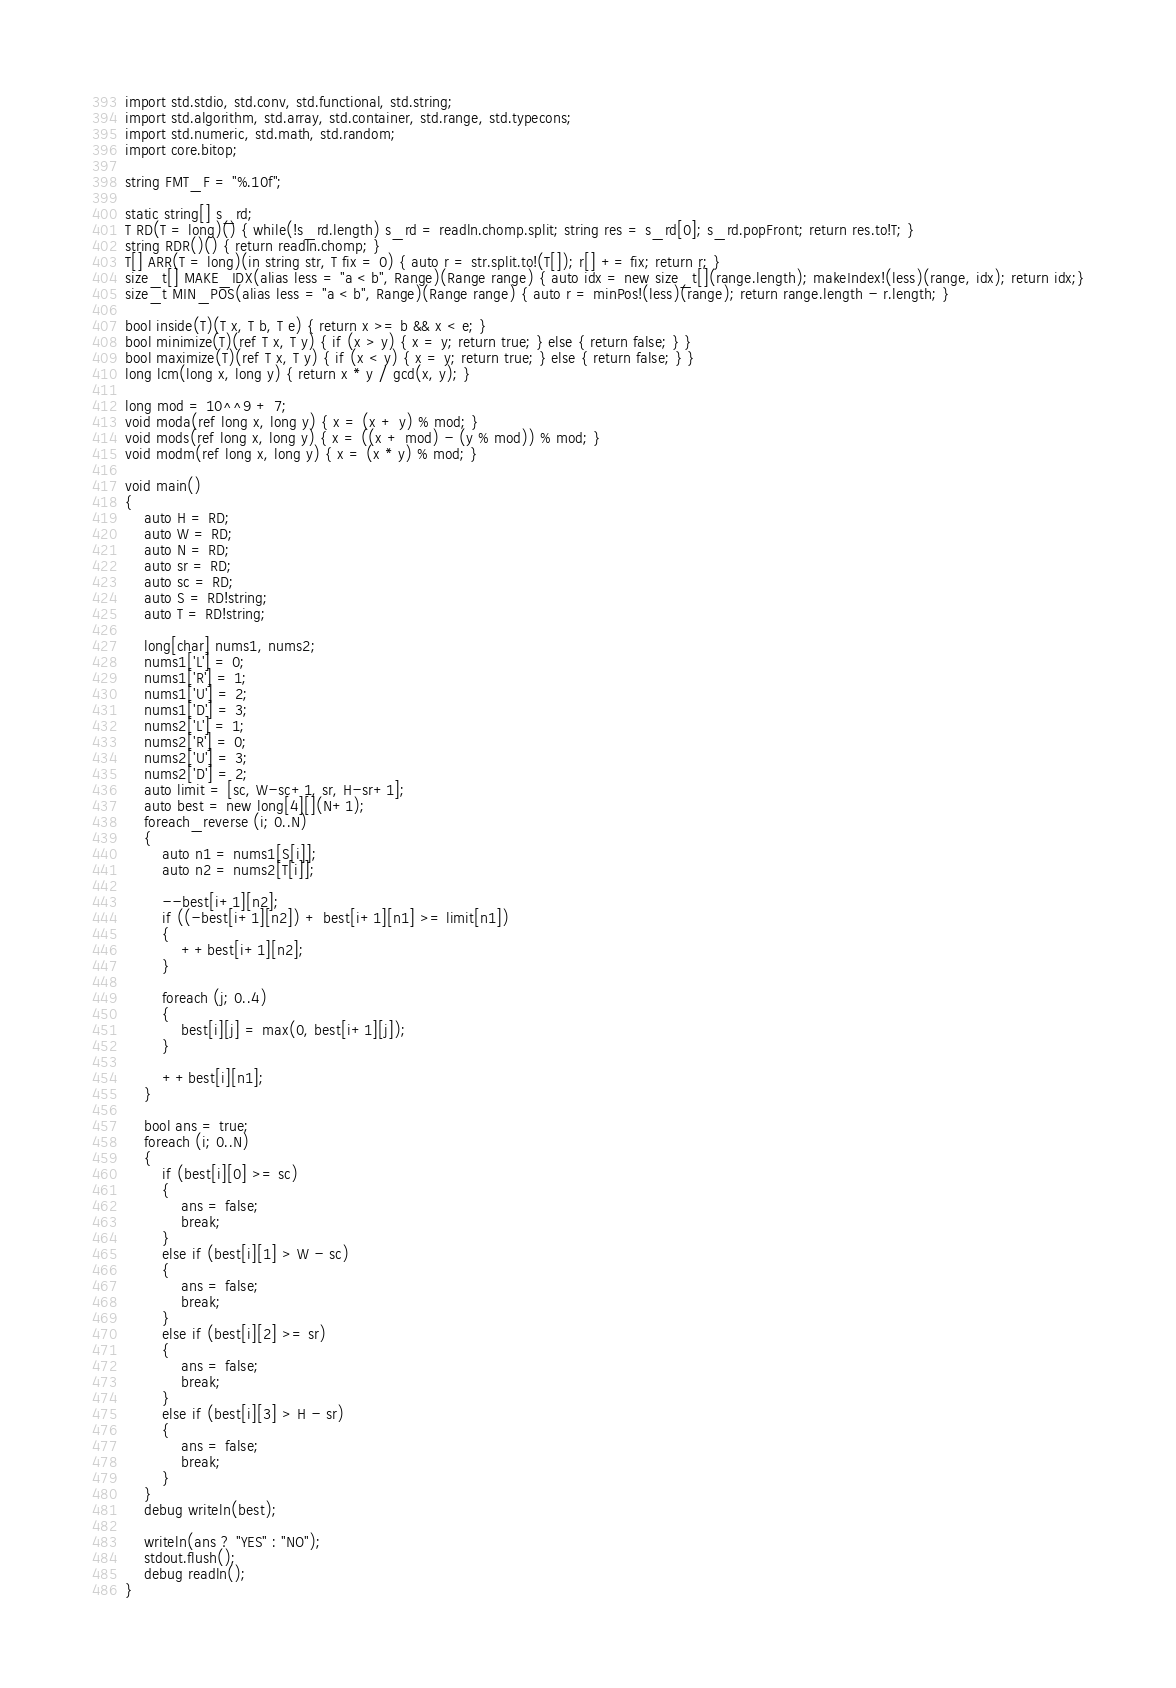<code> <loc_0><loc_0><loc_500><loc_500><_D_>import std.stdio, std.conv, std.functional, std.string;
import std.algorithm, std.array, std.container, std.range, std.typecons;
import std.numeric, std.math, std.random;
import core.bitop;

string FMT_F = "%.10f";

static string[] s_rd;
T RD(T = long)() { while(!s_rd.length) s_rd = readln.chomp.split; string res = s_rd[0]; s_rd.popFront; return res.to!T; }
string RDR()() { return readln.chomp; }
T[] ARR(T = long)(in string str, T fix = 0) { auto r = str.split.to!(T[]); r[] += fix; return r; }
size_t[] MAKE_IDX(alias less = "a < b", Range)(Range range) { auto idx = new size_t[](range.length); makeIndex!(less)(range, idx); return idx;}
size_t MIN_POS(alias less = "a < b", Range)(Range range) { auto r = minPos!(less)(range); return range.length - r.length; }

bool inside(T)(T x, T b, T e) { return x >= b && x < e; }
bool minimize(T)(ref T x, T y) { if (x > y) { x = y; return true; } else { return false; } }
bool maximize(T)(ref T x, T y) { if (x < y) { x = y; return true; } else { return false; } }
long lcm(long x, long y) { return x * y / gcd(x, y); }

long mod = 10^^9 + 7;
void moda(ref long x, long y) { x = (x + y) % mod; }
void mods(ref long x, long y) { x = ((x + mod) - (y % mod)) % mod; }
void modm(ref long x, long y) { x = (x * y) % mod; }

void main()
{
	auto H = RD;
	auto W = RD;
	auto N = RD;
	auto sr = RD;
	auto sc = RD;
	auto S = RD!string;
	auto T = RD!string;

	long[char] nums1, nums2;
	nums1['L'] = 0;
	nums1['R'] = 1;
	nums1['U'] = 2;
	nums1['D'] = 3;
	nums2['L'] = 1;
	nums2['R'] = 0;
	nums2['U'] = 3;
	nums2['D'] = 2;
	auto limit = [sc, W-sc+1, sr, H-sr+1];
	auto best = new long[4][](N+1);
	foreach_reverse (i; 0..N)
	{
		auto n1 = nums1[S[i]];
		auto n2 = nums2[T[i]];

		--best[i+1][n2];
		if ((-best[i+1][n2]) + best[i+1][n1] >= limit[n1])
		{
			++best[i+1][n2];
		}

		foreach (j; 0..4)
		{
			best[i][j] = max(0, best[i+1][j]);
		}

		++best[i][n1];
	}

	bool ans = true;
	foreach (i; 0..N)
	{
		if (best[i][0] >= sc)
		{
			ans = false;
			break;
		}
		else if (best[i][1] > W - sc)
		{
			ans = false;
			break;
		}
		else if (best[i][2] >= sr)
		{
			ans = false;
			break;
		}
		else if (best[i][3] > H - sr)
		{
			ans = false;
			break;
		}
	}
	debug writeln(best);

	writeln(ans ? "YES" : "NO");
	stdout.flush();
	debug readln();
}</code> 